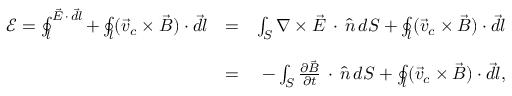<formula> <loc_0><loc_0><loc_500><loc_500>\begin{array} { r l r } { \mathcal { E } = \oint _ { l } ^ { \vec { E } \, \cdot \, \vec { d l } } + \oint _ { l } ( \vec { v } _ { c } \times \vec { B } ) \cdot \vec { d l } } & { = } & { \int _ { S } \nabla \times \vec { E } \, \cdot \, \hat { n } \, d S + \oint _ { l } ( \vec { v } _ { c } \times \vec { B } ) \cdot \vec { d l } } \\ & \\ & { = } & { - \int _ { S } \frac { \partial \vec { B } } { \partial t } \, \cdot \, \hat { n } \, d S + \oint _ { l } ( \vec { v } _ { c } \times \vec { B } ) \cdot \vec { d l } , } \end{array}</formula> 